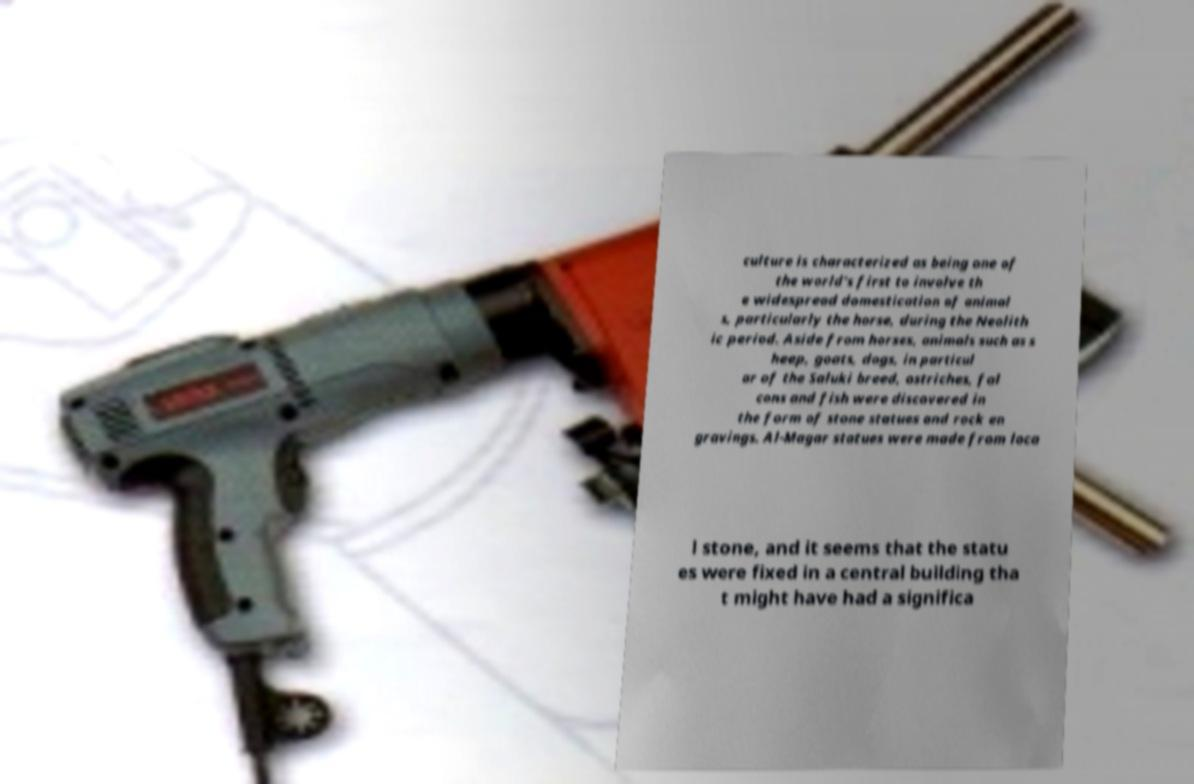Could you extract and type out the text from this image? culture is characterized as being one of the world's first to involve th e widespread domestication of animal s, particularly the horse, during the Neolith ic period. Aside from horses, animals such as s heep, goats, dogs, in particul ar of the Saluki breed, ostriches, fal cons and fish were discovered in the form of stone statues and rock en gravings. Al-Magar statues were made from loca l stone, and it seems that the statu es were fixed in a central building tha t might have had a significa 